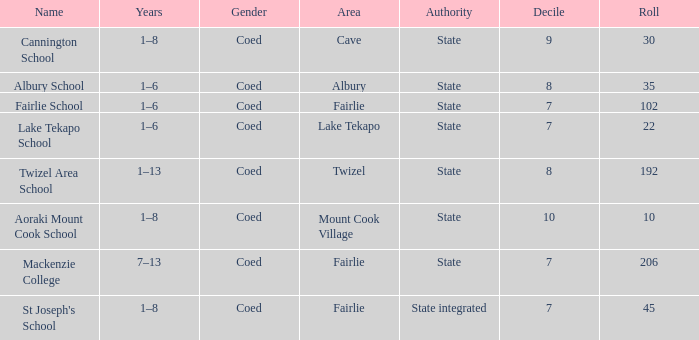Parse the table in full. {'header': ['Name', 'Years', 'Gender', 'Area', 'Authority', 'Decile', 'Roll'], 'rows': [['Cannington School', '1–8', 'Coed', 'Cave', 'State', '9', '30'], ['Albury School', '1–6', 'Coed', 'Albury', 'State', '8', '35'], ['Fairlie School', '1–6', 'Coed', 'Fairlie', 'State', '7', '102'], ['Lake Tekapo School', '1–6', 'Coed', 'Lake Tekapo', 'State', '7', '22'], ['Twizel Area School', '1–13', 'Coed', 'Twizel', 'State', '8', '192'], ['Aoraki Mount Cook School', '1–8', 'Coed', 'Mount Cook Village', 'State', '10', '10'], ['Mackenzie College', '7–13', 'Coed', 'Fairlie', 'State', '7', '206'], ["St Joseph's School", '1–8', 'Coed', 'Fairlie', 'State integrated', '7', '45']]} What area is named Mackenzie college? Fairlie. 